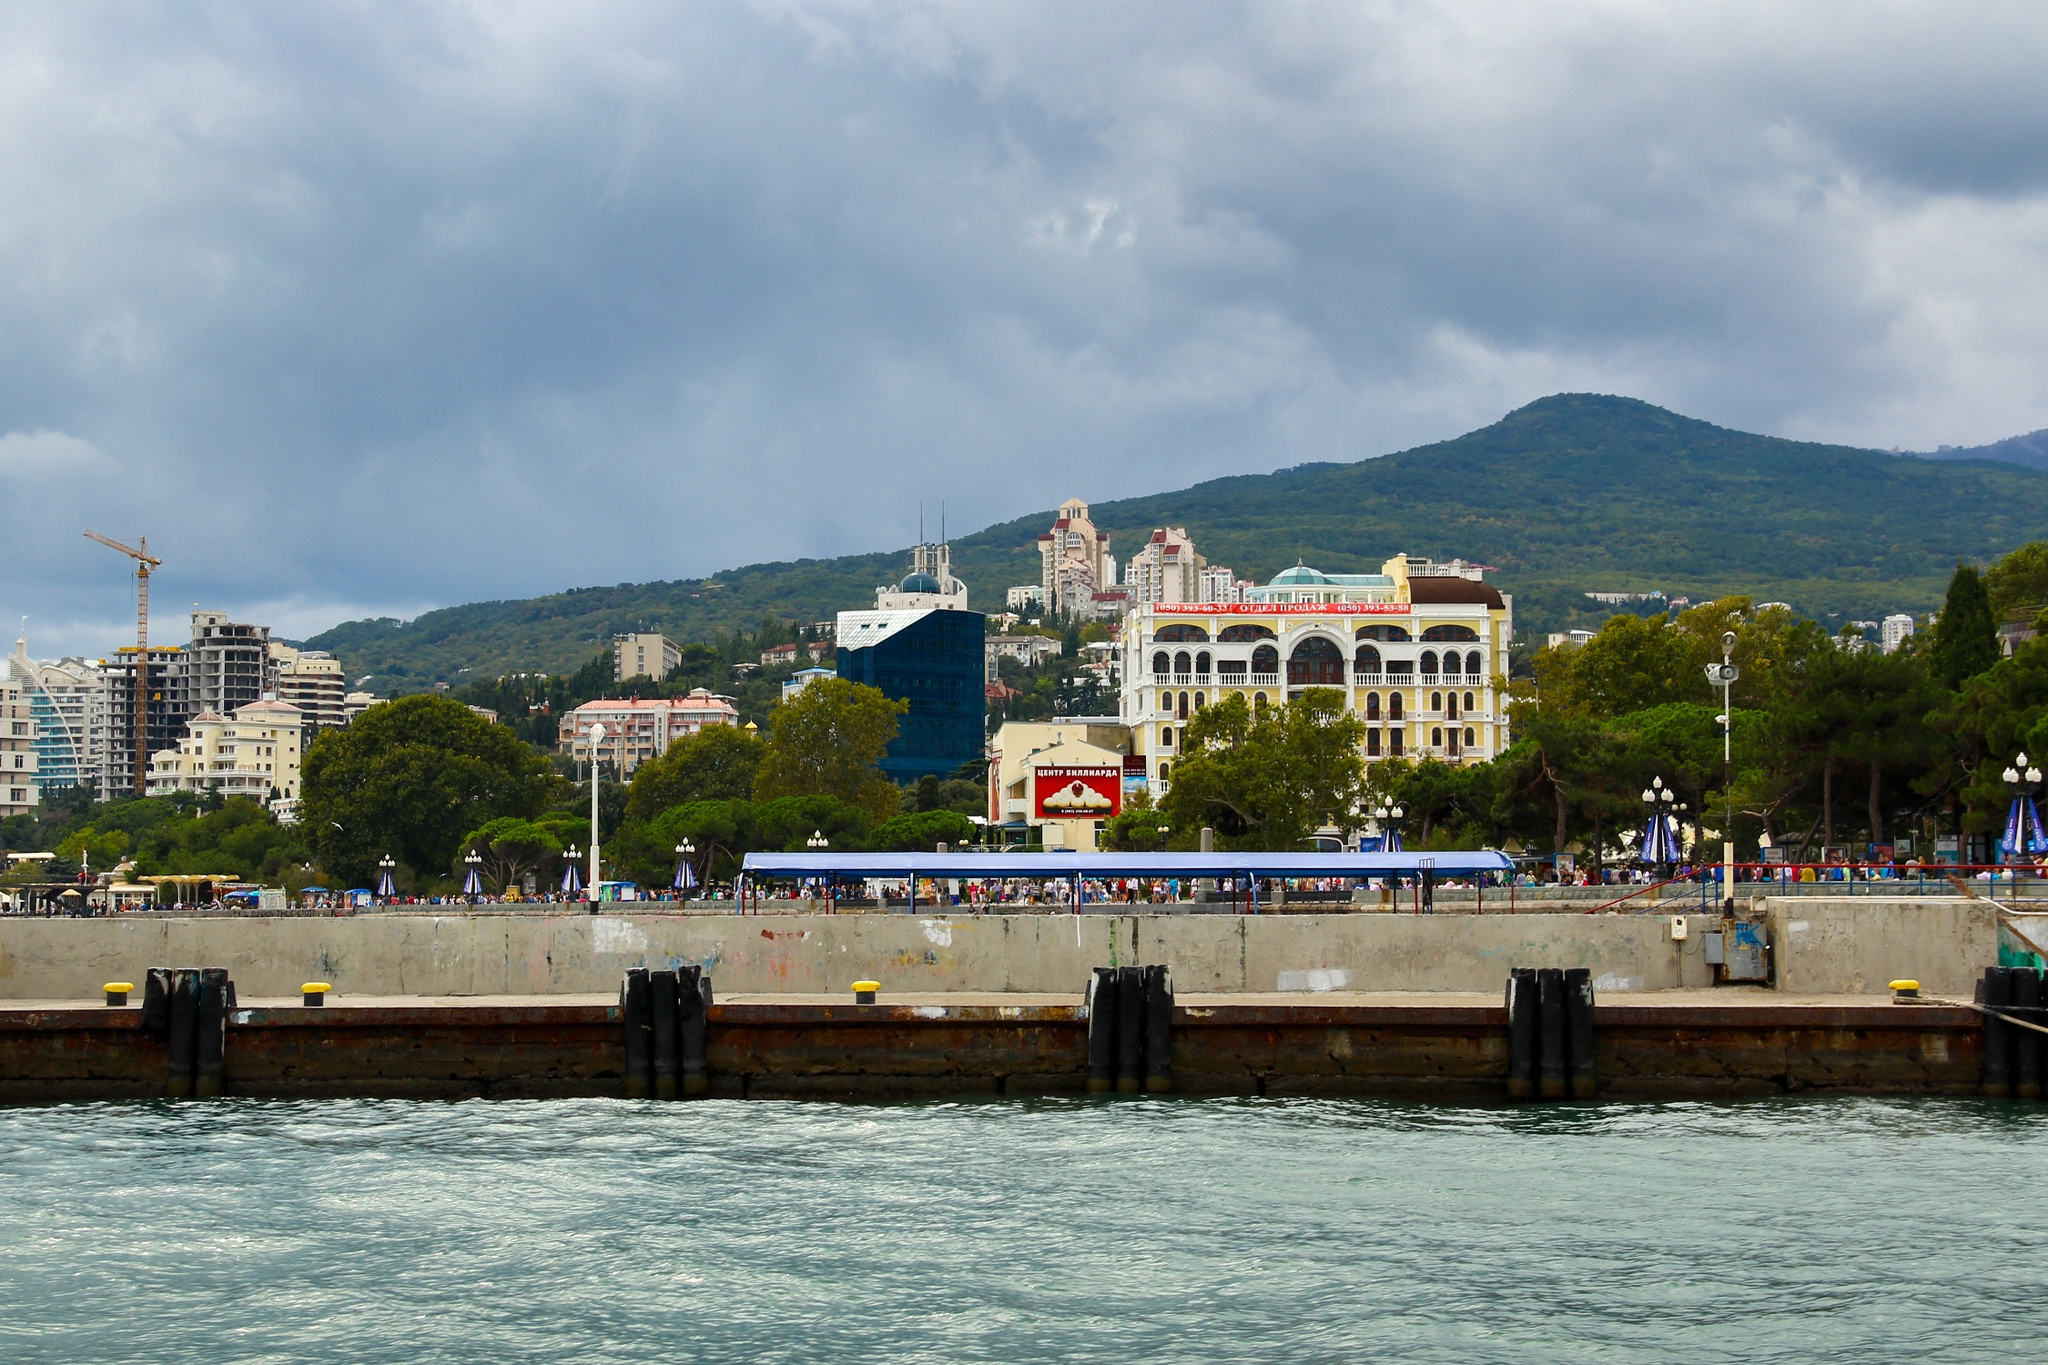Tell me a story about a day in the life of someone visiting this seafront. Imagine a day in the life of Elena, a visitor to the Yalta seafront. She starts her morning with a stroll along the bustling pier, the fresh sea breeze invigorating her senses. The sun peeks through the clouds, casting a gentle light on the lively crowd around her. She finds a quaint cafe near the striking blue building, where she enjoys a delicious breakfast with a view of the sparkling water. After breakfast, she explores the architectural wonders behind the pier, admiring the blend of traditional and modern styles. As the day progresses, Elena visits a local market, where she buys unique souvenirs and sharegpt4v/samples local delicacies. In the afternoon, she relaxes on a bench, soaking in the vibrant atmosphere and the serene beauty of the hills in the background. As the day winds down, Elena finds a spot at a waterfront restaurant to enjoy a picturesque sunset, reflecting on a day rich with new experiences and cultural discoveries. 